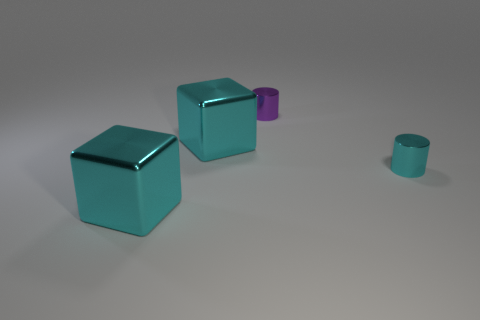There is a cube that is behind the tiny shiny thing right of the small purple metallic thing; what color is it? cyan 